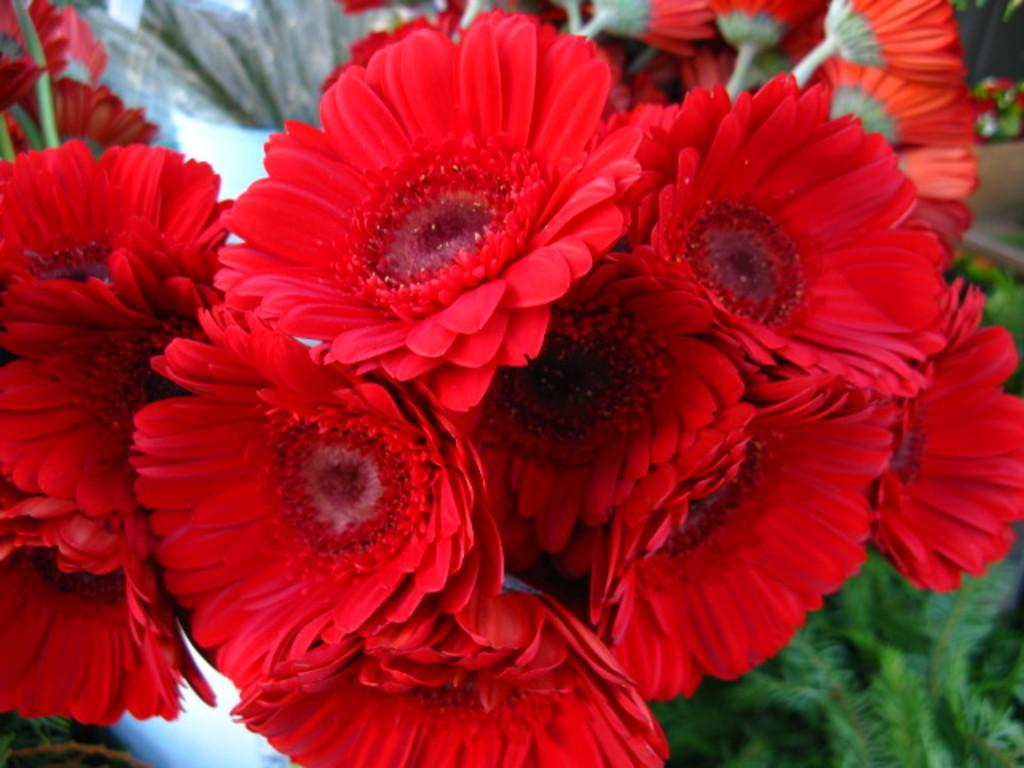What type of flowers can be seen in the image? There are red color flowers in the image. What else can be seen in the background of the image? There are leaves visible in the background of the image. Can you see a stream of water flowing through the flowers in the image? There is no stream of water visible in the image; it only features red color flowers and leaves in the background. 